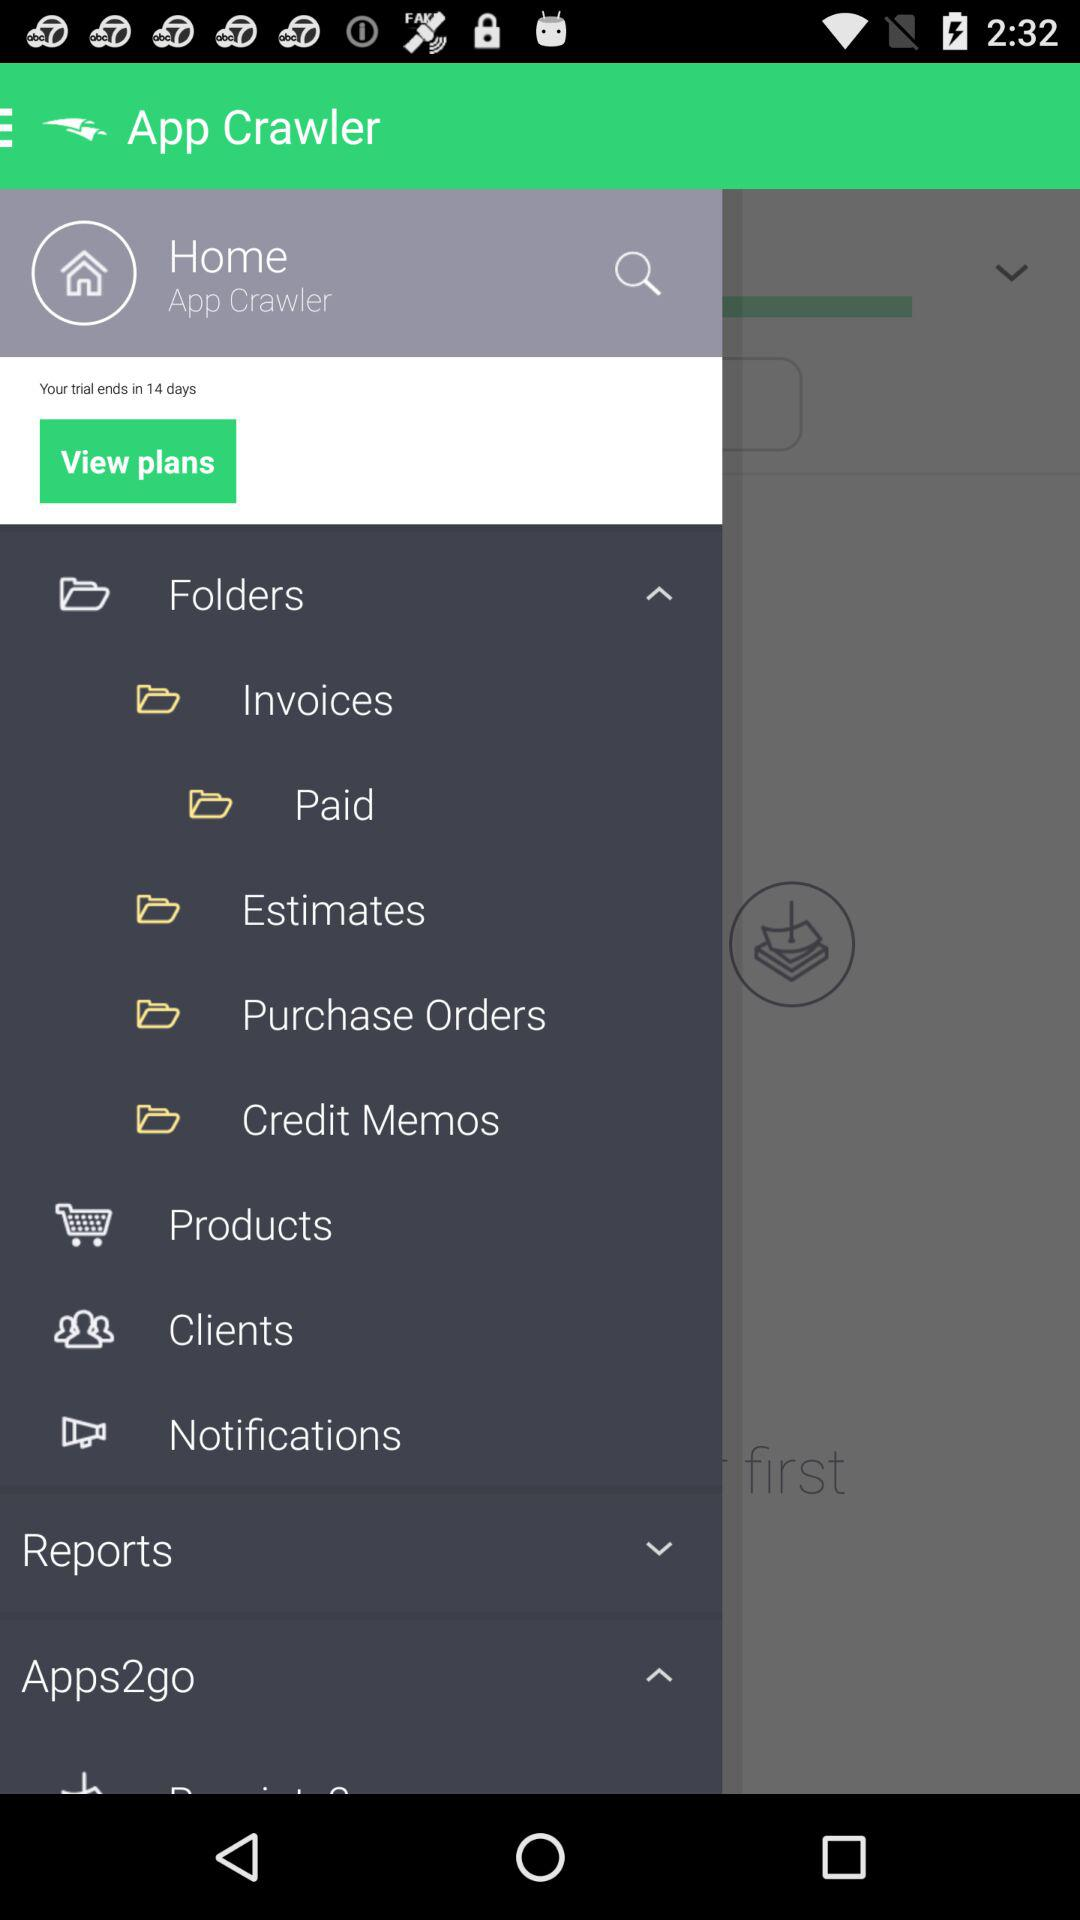What is the name of the user? The user name is App Crawler. 